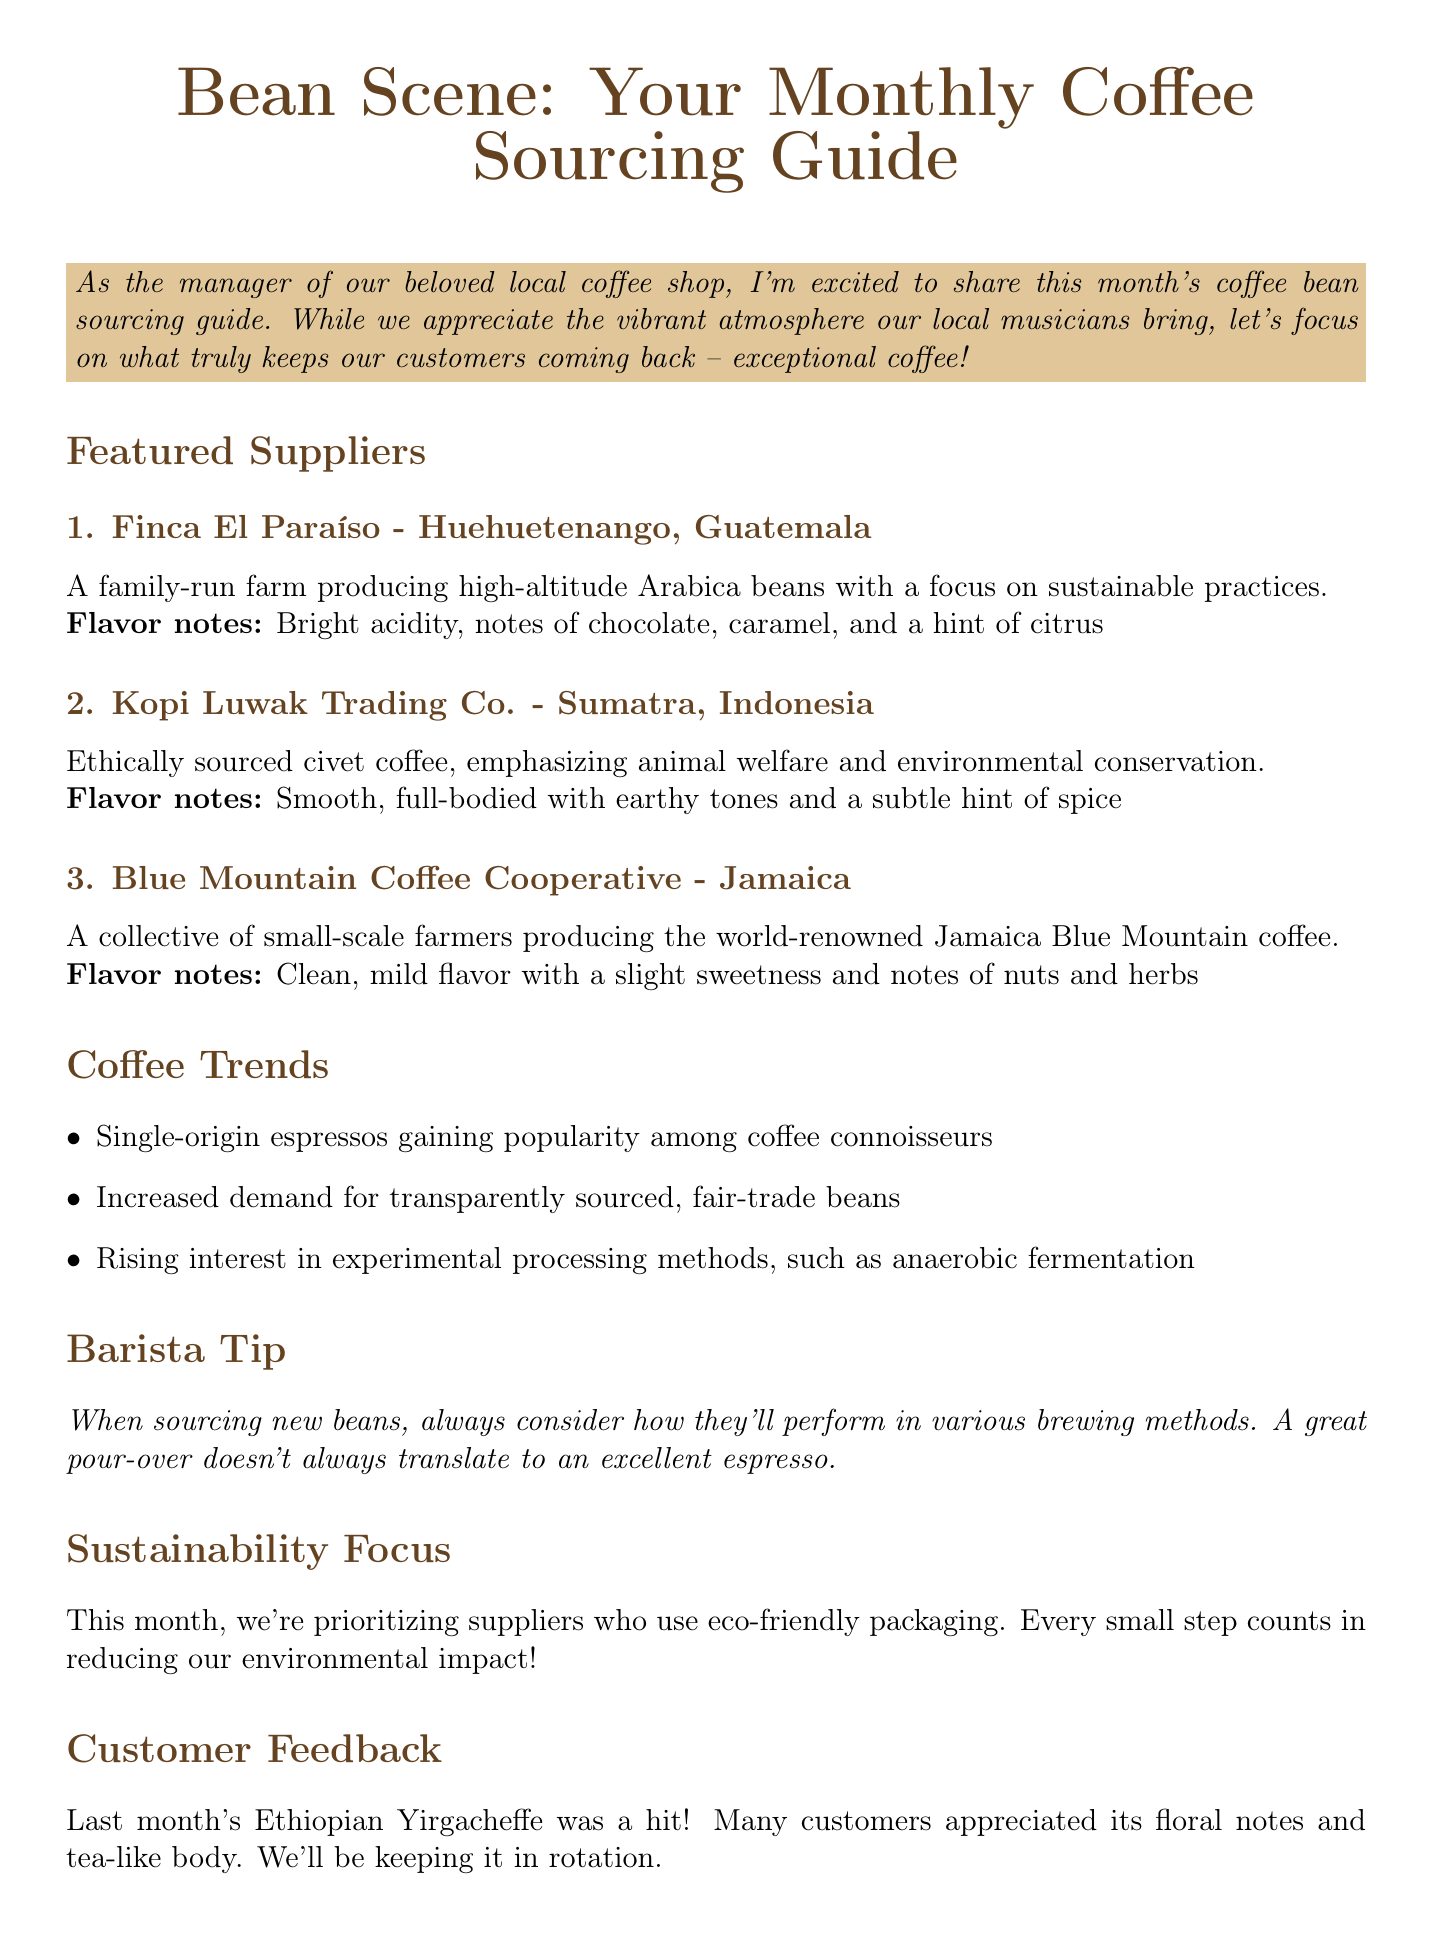What is the title of the newsletter? The title is explicitly mentioned at the beginning of the document.
Answer: Bean Scene: Your Monthly Coffee Sourcing Guide How many featured suppliers are listed? The document lists three suppliers under the featured suppliers section.
Answer: 3 What flavor notes are associated with Finca El Paraíso? The flavor notes are specified directly under the supplier's profile.
Answer: Bright acidity, notes of chocolate, caramel, and a hint of citrus What is the date of the upcoming cupping session? The date is mentioned in the upcoming cupping session section.
Answer: May 15, 2023 What sustainability focus is highlighted this month? The document states the specific sustainability focus in this section.
Answer: Eco-friendly packaging What is the barista tip provided in the newsletter? The tip is quoted directly in the barista tip section.
Answer: When sourcing new beans, always consider how they'll perform in various brewing methods Which coffee trend is related to fair-trade beans? This information is referenced in the coffee trends section as a demand trend.
Answer: Increased demand for transparently sourced, fair-trade beans What feedback did customers give about last month's coffee? The customer feedback section provides insight into what customers thought about the coffee.
Answer: Many customers appreciated its floral notes and tea-like body 